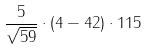Convert formula to latex. <formula><loc_0><loc_0><loc_500><loc_500>\frac { 5 } { \sqrt { 5 9 } } \cdot ( 4 - 4 2 ) \cdot 1 1 5</formula> 